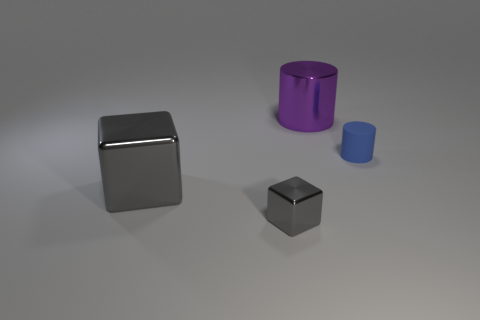Add 1 metallic objects. How many objects exist? 5 Subtract 0 gray balls. How many objects are left? 4 Subtract all small blue rubber things. Subtract all small red metal cubes. How many objects are left? 3 Add 4 large purple metallic things. How many large purple metallic things are left? 5 Add 4 tiny cubes. How many tiny cubes exist? 5 